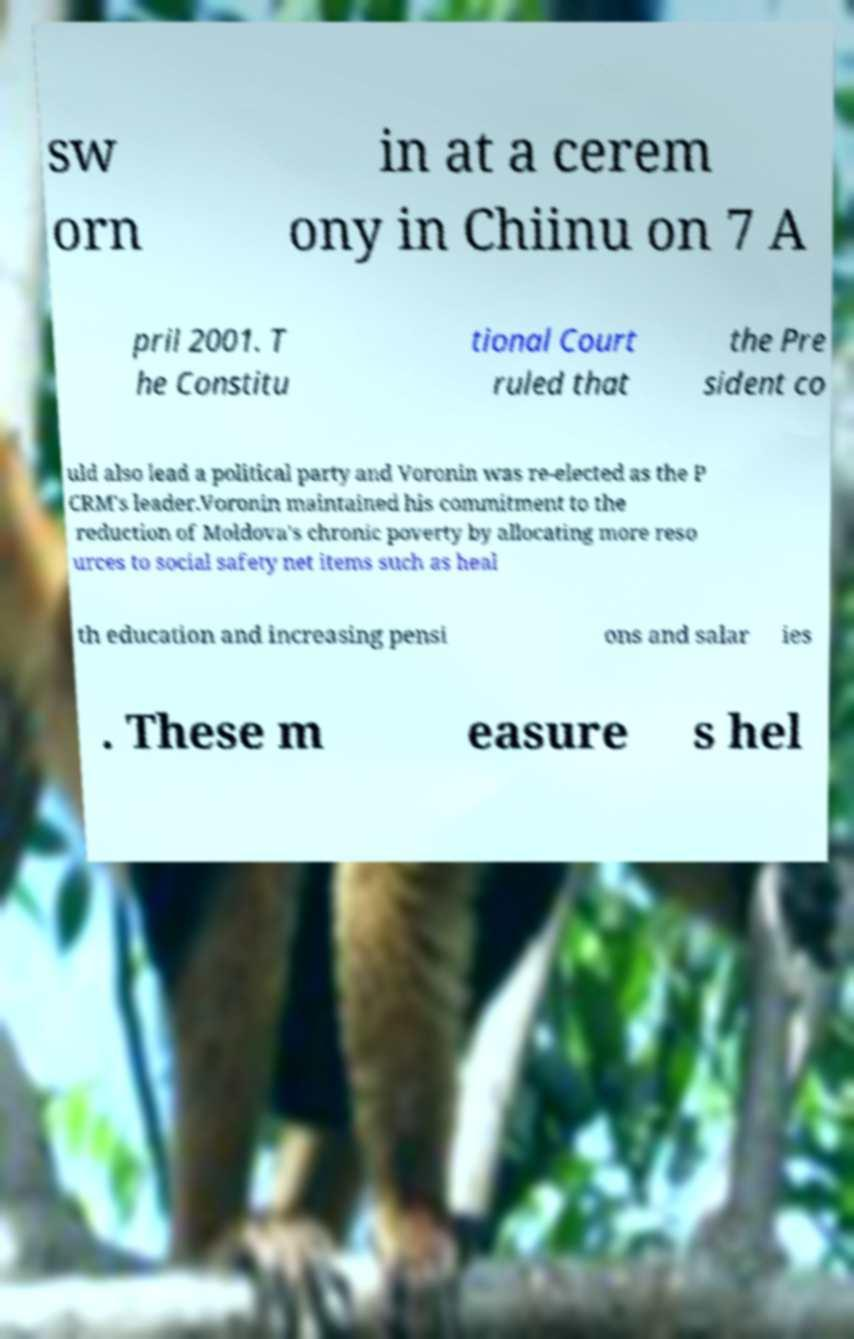What messages or text are displayed in this image? I need them in a readable, typed format. sw orn in at a cerem ony in Chiinu on 7 A pril 2001. T he Constitu tional Court ruled that the Pre sident co uld also lead a political party and Voronin was re-elected as the P CRM's leader.Voronin maintained his commitment to the reduction of Moldova's chronic poverty by allocating more reso urces to social safety net items such as heal th education and increasing pensi ons and salar ies . These m easure s hel 